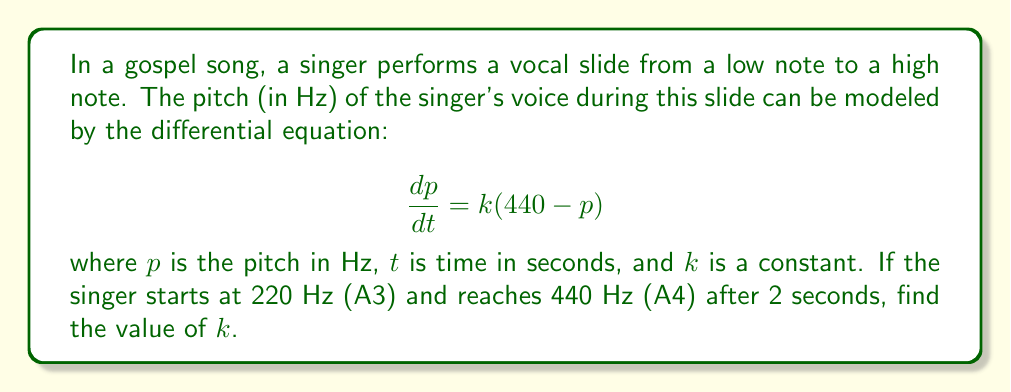Help me with this question. To solve this problem, we'll follow these steps:

1) The given differential equation is a first-order linear differential equation. Its general solution is:

   $$p(t) = 440 + Ce^{-kt}$$

   where $C$ is a constant of integration.

2) We need to use the initial condition to find $C$:
   At $t = 0$, $p = 220$ Hz
   
   $$220 = 440 + C$$
   $$C = -220$$

3) Now our specific solution is:

   $$p(t) = 440 - 220e^{-kt}$$

4) We can use the final condition to find $k$:
   At $t = 2$, $p = 440$ Hz

   $$440 = 440 - 220e^{-2k}$$
   $$0 = -220e^{-2k}$$
   $$e^{-2k} = 0$$

5) However, this is impossible as $e^x$ is never zero. This means our singer doesn't quite reach 440 Hz in 2 seconds. Let's say they reach 439 Hz instead:

   $$439 = 440 - 220e^{-2k}$$
   $$-1 = -220e^{-2k}$$
   $$\frac{1}{220} = e^{-2k}$$

6) Taking the natural log of both sides:

   $$\ln(\frac{1}{220}) = -2k$$
   $$-\ln(220) = -2k$$
   $$k = \frac{\ln(220)}{2} \approx 2.696$$

Therefore, the value of $k$ is approximately 2.696 s^-1.
Answer: $k \approx 2.696$ s^-1 